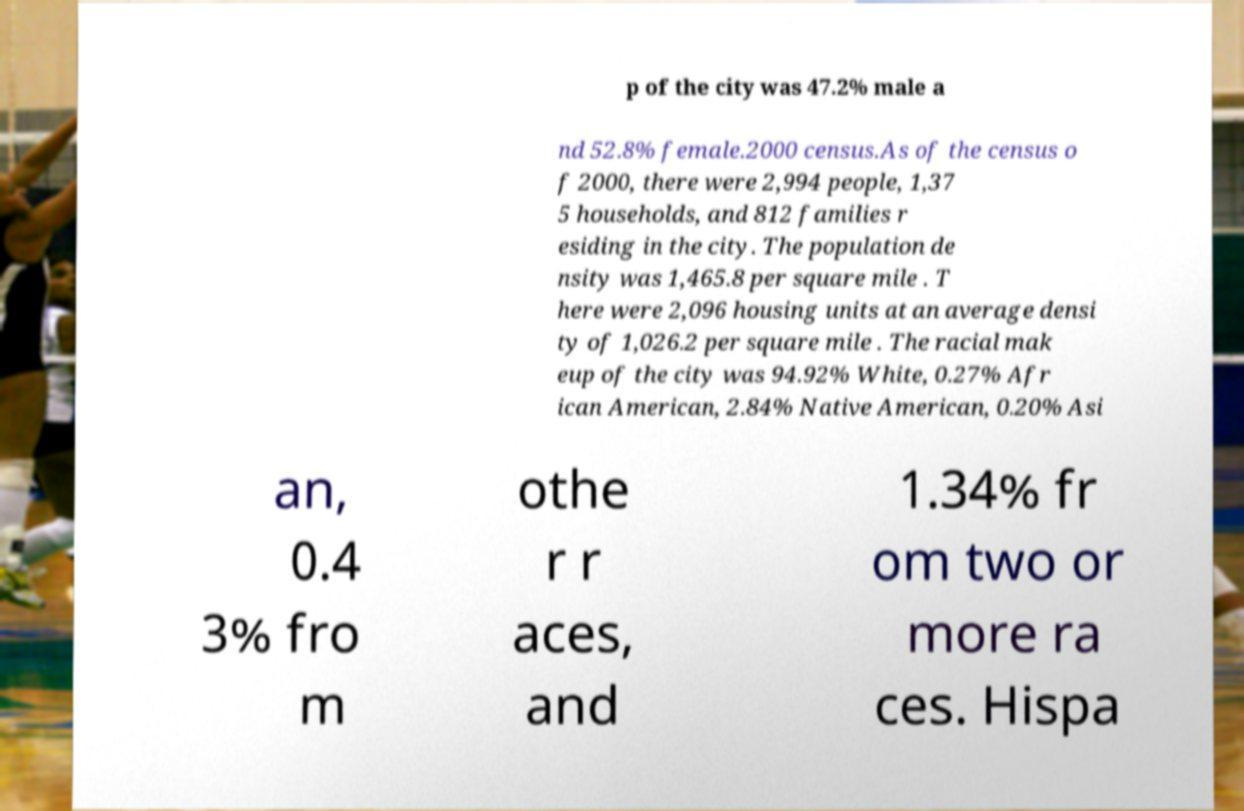What messages or text are displayed in this image? I need them in a readable, typed format. p of the city was 47.2% male a nd 52.8% female.2000 census.As of the census o f 2000, there were 2,994 people, 1,37 5 households, and 812 families r esiding in the city. The population de nsity was 1,465.8 per square mile . T here were 2,096 housing units at an average densi ty of 1,026.2 per square mile . The racial mak eup of the city was 94.92% White, 0.27% Afr ican American, 2.84% Native American, 0.20% Asi an, 0.4 3% fro m othe r r aces, and 1.34% fr om two or more ra ces. Hispa 